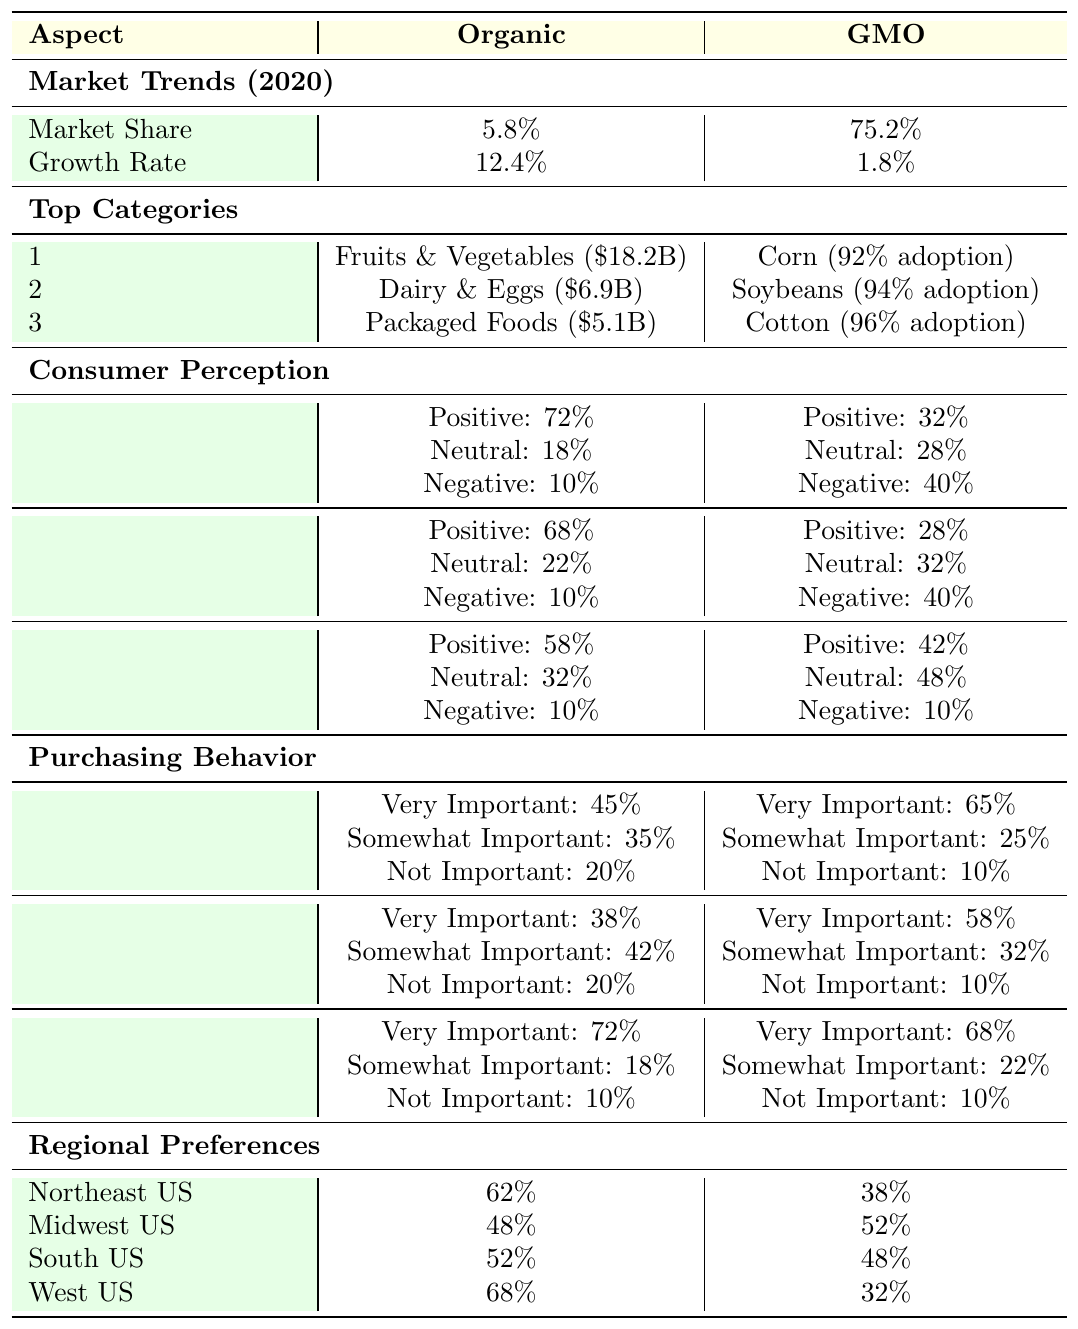What is the market share of organic products in 2020? According to the table in the "Market Trends" section under "Organic Market," the market share of organic products in 2020 is listed as 5.8%.
Answer: 5.8% What is the growth rate of GMO products compared to organic products in 2020? In the table, under "Growth Rate," organic products have a rate of 12.4% while GMO products have a rate of 1.8%. The difference between their growth rates can be calculated as 12.4% - 1.8% = 10.6%.
Answer: 10.6% What percentage of consumers have a positive perception of organic products regarding health? In the "Consumer Perception" section under the aspect of "Health," the positive perception of organic products is stated as 72%.
Answer: 72% Which aspect has the highest positive perception for organic products? By reviewing the positive perception percentages for each aspect—Health (72%), Environmental Impact (68%), and Taste (58%)—we see that Health has the highest positive perception among organic products.
Answer: Health How much more critical is the factor of labeling for organic products compared to GMO products? For organic products, 72% consider labeling "Very Important," while for GMO products, it is 68%. The difference is 72% - 68% = 4%, indicating that organic consumers value labeling slightly more.
Answer: 4% Is the preference for organic products higher in the Northeast or the Midwest US? The table shows that the organic preference in the Northeast is 62%, while in the Midwest it's 48%. Thus, the Northeast has a higher preference for organic products compared to the Midwest.
Answer: Yes What is the average positive perception percentage for GMO products across health, environmental impact, and taste? The positive perceptions for GMO products are 32% (Health), 28% (Environmental Impact), and 42% (Taste). The average is calculated as (32% + 28% + 42%) / 3 = 34%.
Answer: 34% Which category in the organic market has the highest sales? In the "Top Categories" under "Organic Market," Fruits and Vegetables have the highest sales at $18.2 billion compared to Dairy and Eggs ($6.9 billion) and Packaged Foods ($5.1 billion).
Answer: Fruits and Vegetables Are organic products generally viewed more positively than GMO products when it comes to environmental impact? The table indicates that 68% of consumers have a positive perception of organic products for environmental impact, whereas only 28% feel the same about GMO products, showing that organic products are indeed viewed more positively.
Answer: Yes What percentage of consumers think price is "Not Important" when purchasing organic products? According to the "Purchasing Behavior" section under the factor of "Price," 20% of consumers stated that price is "Not Important" when considering organic purchases.
Answer: 20% 